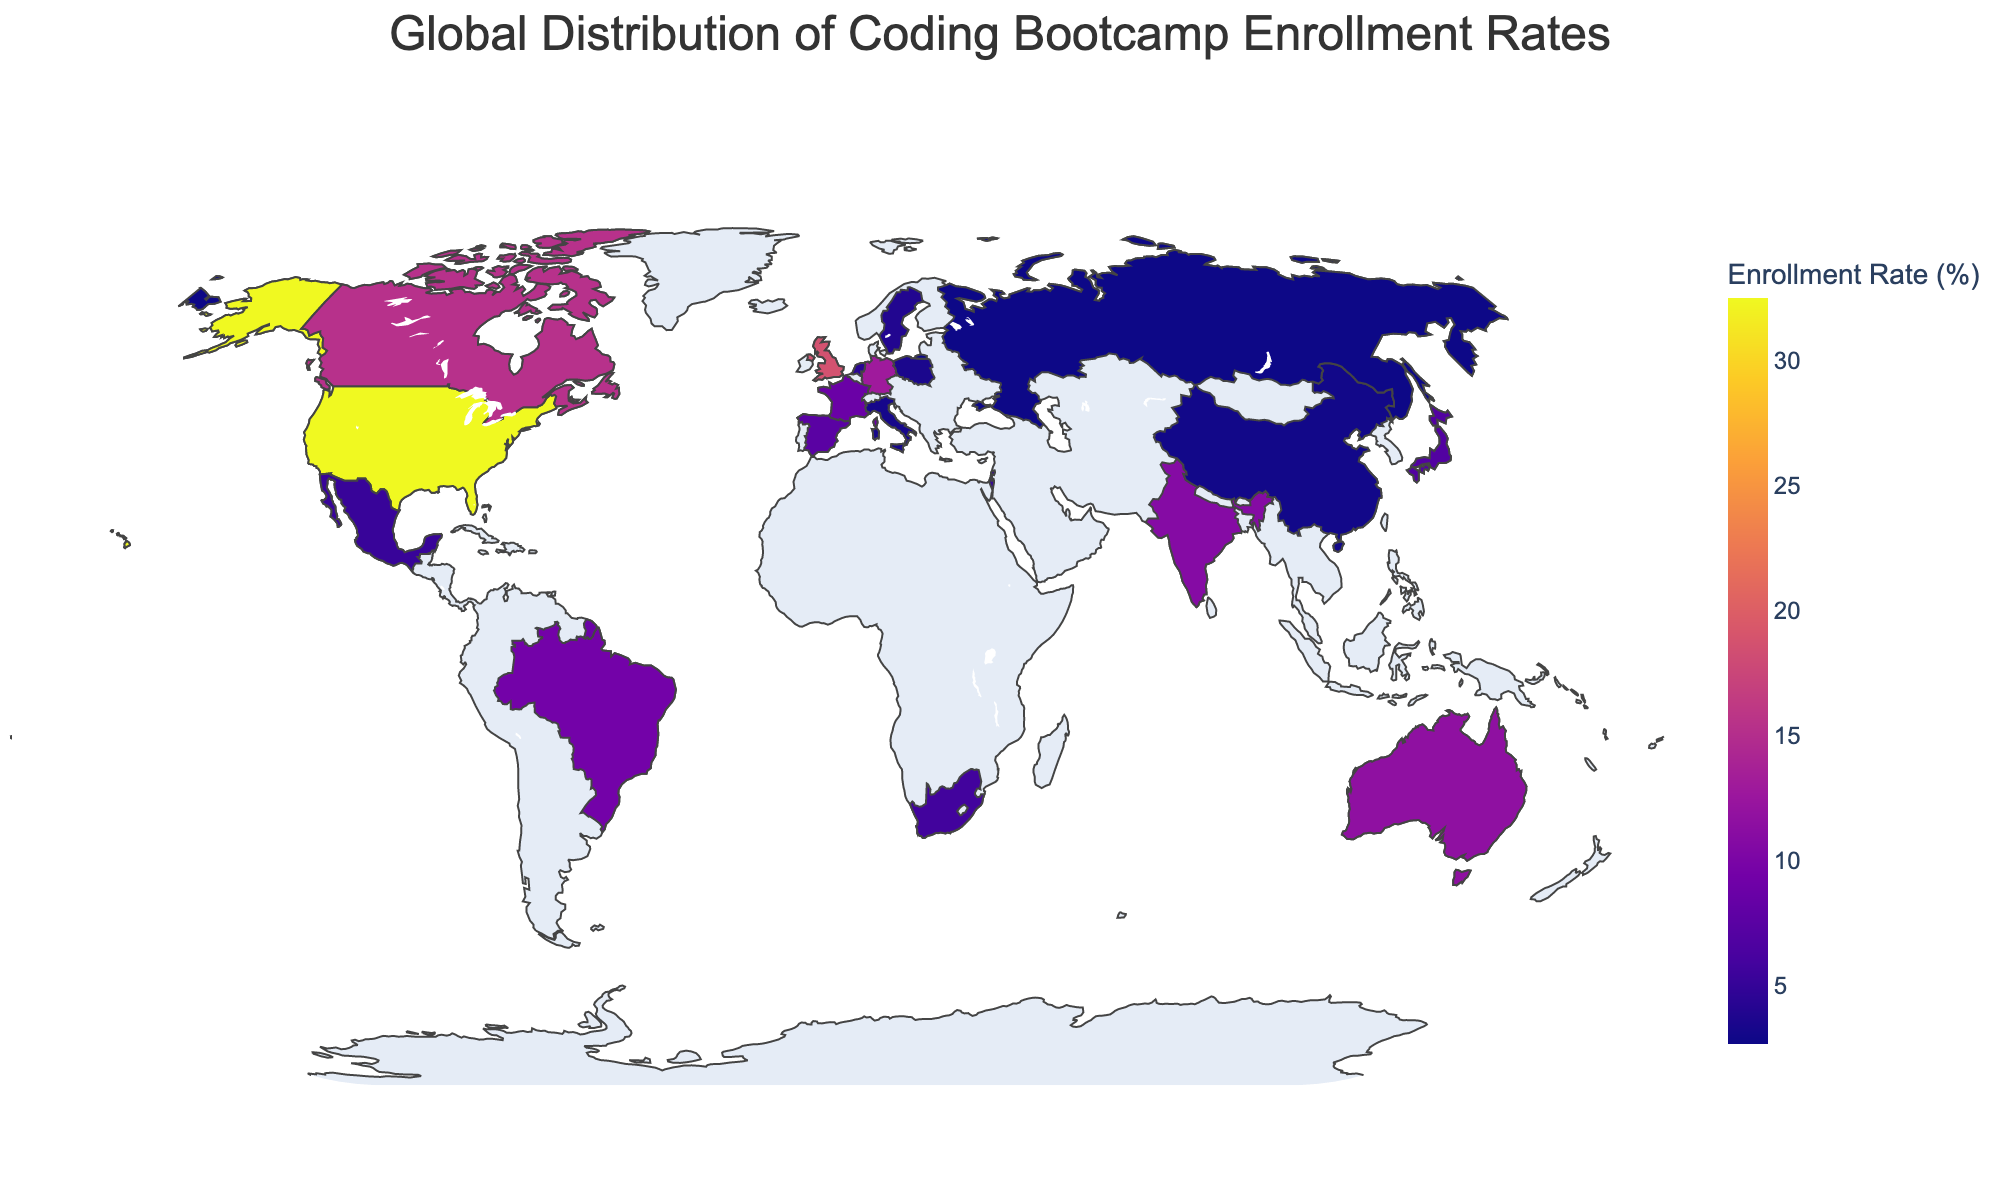What's the title of the figure? The title of the figure should be located at the top center as per standard plot conventions. The title typically describes what the figure is about. In this case, it reflects the data provided.
Answer: Global Distribution of Coding Bootcamp Enrollment Rates Which country has the highest enrollment rate? Look for the country with the darkest shade in the figure, as higher enrollment rates would correlate with darker colors due to the color scale used. Cross-referencing with the legend or hovering over the country name will confirm.
Answer: United States What is the enrollment rate of Japan? Identify Japan on the map and check its corresponding color. Hovering over Japan will display detailed information, including the enrollment rate.
Answer: 6.9% Compare the enrollment rates of Germany and France. Which country has a higher rate? Locate Germany and France on the map, check their colors and hover over them to get the exact rates. Germany's color will show it is higher.
Answer: Germany How many countries have an enrollment rate below 5%? Identify countries shaded in the lighter colors corresponding to the rates below 5% on the color bar. Count these countries.
Answer: 5 What is the combined enrollment rate of Australia and Canada? Find Australia and Canada, note their enrollment rates, and sum these values. Australia's rate is 11.6% and Canada's is 15.3%. Calculate the sum: 11.6 + 15.3 = 26.9.
Answer: 26.9% Describe the color scale used for enrollment rates. Observe the variation of colors across the countries on the map. The color scale used is Plasma, ranging from lighter to darker shades representing lower to higher enrollment rates.
Answer: Plasma color scale Which continent has the most diverse enrollment rates? Examine the spread and color differences of countries within each continent. Look for the continent with the widest variation in colors/shades.
Answer: Europe For the country with the lowest enrollment rate, provide the rate and the country name. Identify the country with the lightest shade and hover to get its enrollment rate and name.
Answer: Russia, 2.7% What is the average enrollment rate of the countries listed in the data? Sum the enrollment rates of all countries listed and then divide by the number of countries. Sum: 32.5 + 18.7 + 15.3 + 12.9 + 11.6 + 10.8 + 9.4 + 8.7 + 7.5 + 6.9 + 5.8 + 5.2 + 4.9 + 4.6 + 4.3 + 3.9 + 3.5 + 3.2 + 3.0 + 2.7 = 181.4. Number of countries: 20. Average: 181.4 / 20 = 9.07.
Answer: 9.07% 